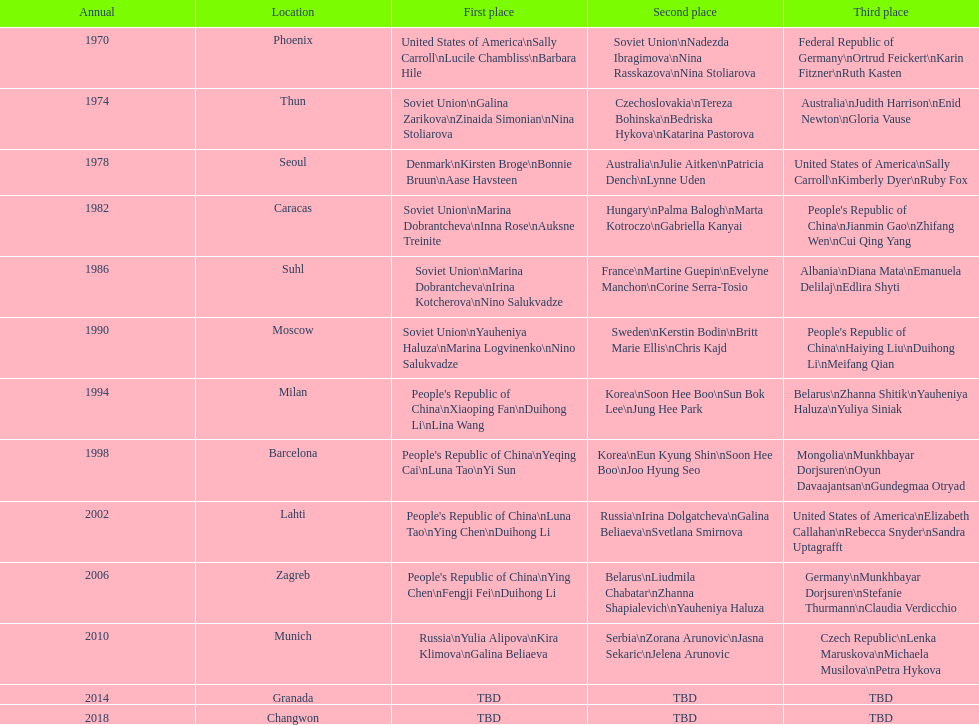How many world championships had the soviet union won first place in in the 25 metre pistol women's world championship? 4. 